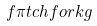Convert formula to latex. <formula><loc_0><loc_0><loc_500><loc_500>f \pi t c h f o r k g</formula> 